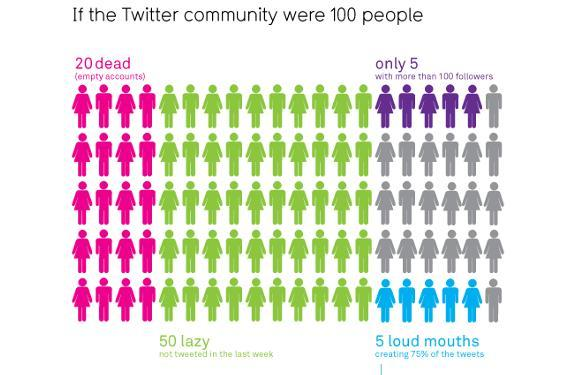Which color used to represent lazy-pink, violet, green, blue?
Answer the question with a short phrase. green Which color used to represent empty account-green, violet, pink, blue? pink 